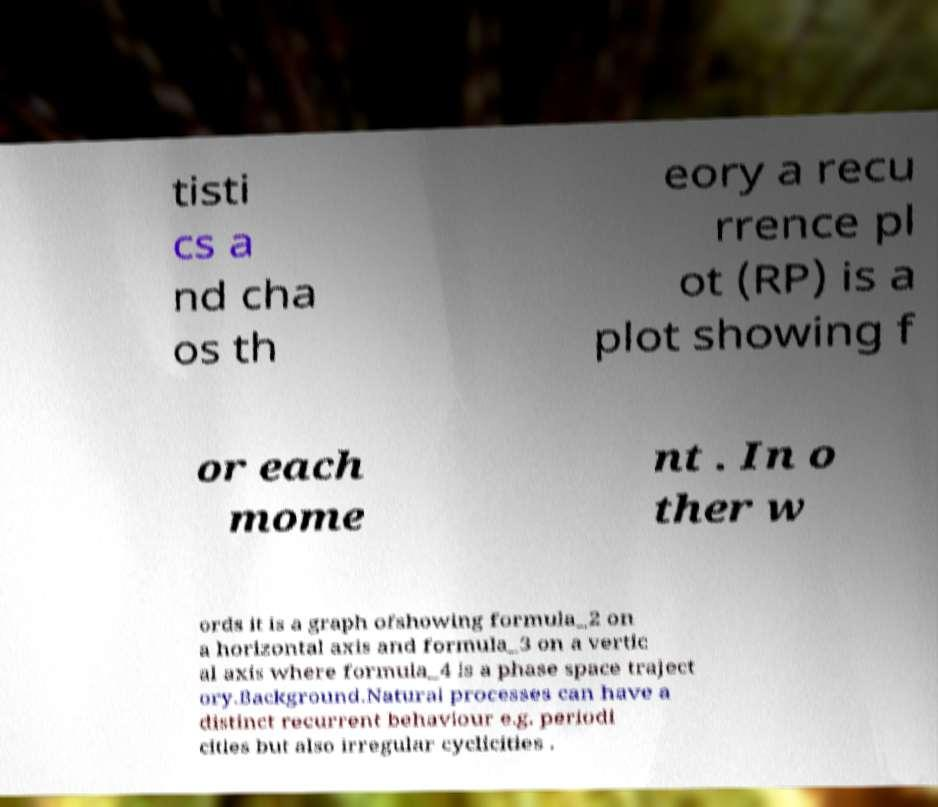There's text embedded in this image that I need extracted. Can you transcribe it verbatim? tisti cs a nd cha os th eory a recu rrence pl ot (RP) is a plot showing f or each mome nt . In o ther w ords it is a graph ofshowing formula_2 on a horizontal axis and formula_3 on a vertic al axis where formula_4 is a phase space traject ory.Background.Natural processes can have a distinct recurrent behaviour e.g. periodi cities but also irregular cyclicities . 